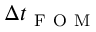<formula> <loc_0><loc_0><loc_500><loc_500>\Delta t _ { F O M }</formula> 